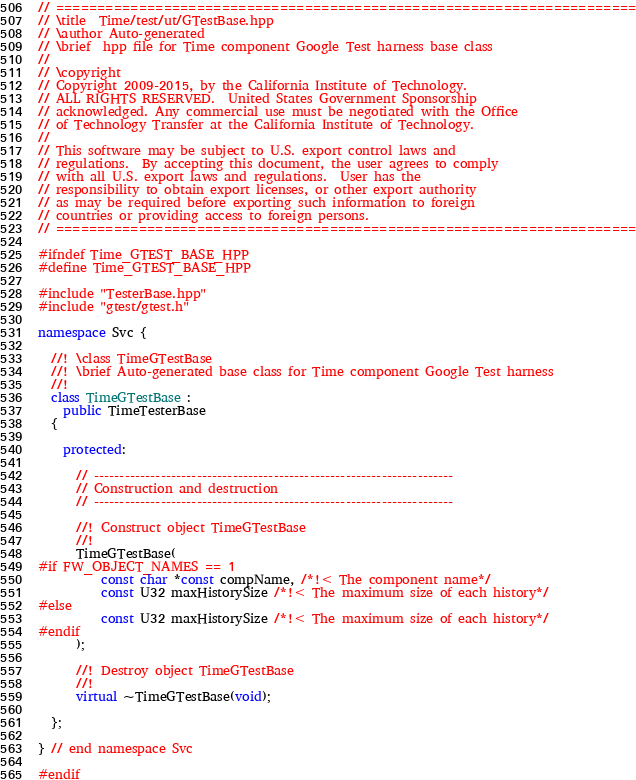Convert code to text. <code><loc_0><loc_0><loc_500><loc_500><_C++_>// ======================================================================
// \title  Time/test/ut/GTestBase.hpp
// \author Auto-generated
// \brief  hpp file for Time component Google Test harness base class
//
// \copyright
// Copyright 2009-2015, by the California Institute of Technology.
// ALL RIGHTS RESERVED.  United States Government Sponsorship
// acknowledged. Any commercial use must be negotiated with the Office
// of Technology Transfer at the California Institute of Technology.
//
// This software may be subject to U.S. export control laws and
// regulations.  By accepting this document, the user agrees to comply
// with all U.S. export laws and regulations.  User has the
// responsibility to obtain export licenses, or other export authority
// as may be required before exporting such information to foreign
// countries or providing access to foreign persons.
// ======================================================================

#ifndef Time_GTEST_BASE_HPP
#define Time_GTEST_BASE_HPP

#include "TesterBase.hpp"
#include "gtest/gtest.h"

namespace Svc {

  //! \class TimeGTestBase
  //! \brief Auto-generated base class for Time component Google Test harness
  //!
  class TimeGTestBase :
    public TimeTesterBase
  {

    protected:

      // ----------------------------------------------------------------------
      // Construction and destruction
      // ----------------------------------------------------------------------

      //! Construct object TimeGTestBase
      //!
      TimeGTestBase(
#if FW_OBJECT_NAMES == 1
          const char *const compName, /*!< The component name*/
          const U32 maxHistorySize /*!< The maximum size of each history*/
#else
          const U32 maxHistorySize /*!< The maximum size of each history*/
#endif
      );

      //! Destroy object TimeGTestBase
      //!
      virtual ~TimeGTestBase(void);

  };

} // end namespace Svc

#endif
</code> 